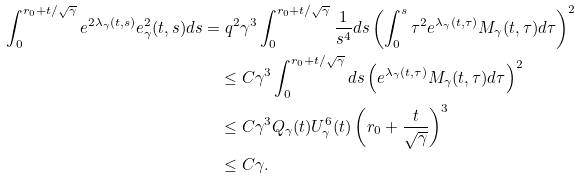<formula> <loc_0><loc_0><loc_500><loc_500>\int _ { 0 } ^ { r _ { 0 } + t / \sqrt { \gamma } } e ^ { 2 \lambda _ { \gamma } ( t , s ) } e _ { \gamma } ^ { 2 } ( t , s ) d s & = q ^ { 2 } \gamma ^ { 3 } \int _ { 0 } ^ { r _ { 0 } + t / \sqrt { \gamma } } \frac { 1 } { s ^ { 4 } } d s \left ( \int _ { 0 } ^ { s } \tau ^ { 2 } e ^ { \lambda _ { \gamma } ( t , \tau ) } M _ { \gamma } ( t , \tau ) d \tau \right ) ^ { 2 } \\ & \quad \leq C \gamma ^ { 3 } \int _ { 0 } ^ { r _ { 0 } + t / \sqrt { \gamma } } d s \left ( e ^ { \lambda _ { \gamma } ( t , \tau ) } M _ { \gamma } ( t , \tau ) d \tau \right ) ^ { 2 } \\ & \quad \leq C \gamma ^ { 3 } Q _ { \gamma } ( t ) U _ { \gamma } ^ { 6 } ( t ) \left ( r _ { 0 } + \frac { t } { \sqrt { \gamma } } \right ) ^ { 3 } \\ & \quad \leq C \gamma .</formula> 